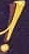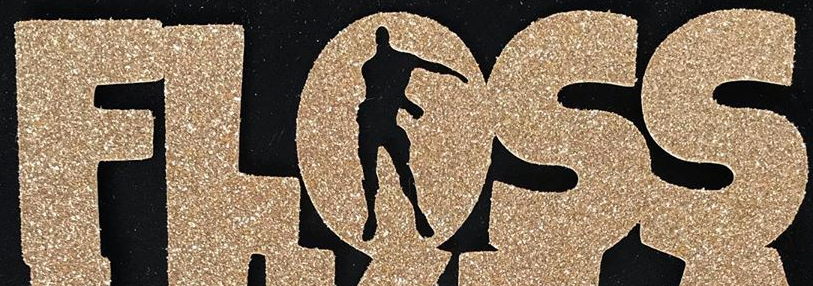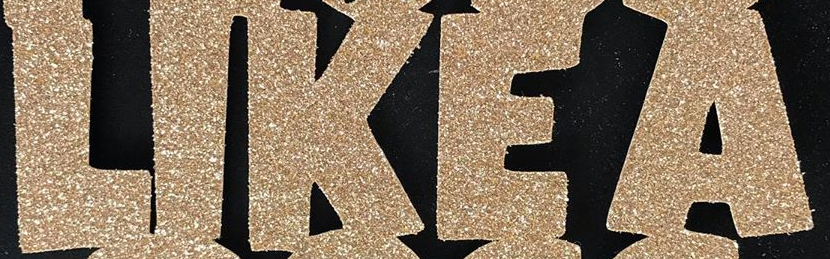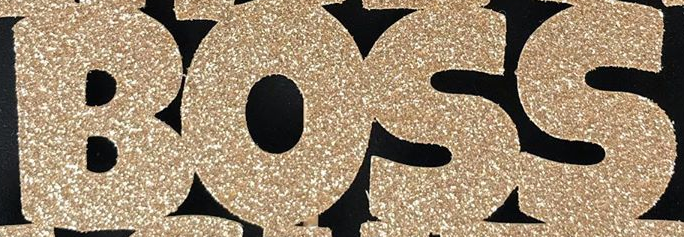What text appears in these images from left to right, separated by a semicolon? !; FLOSS; LIKEA; BOSS 